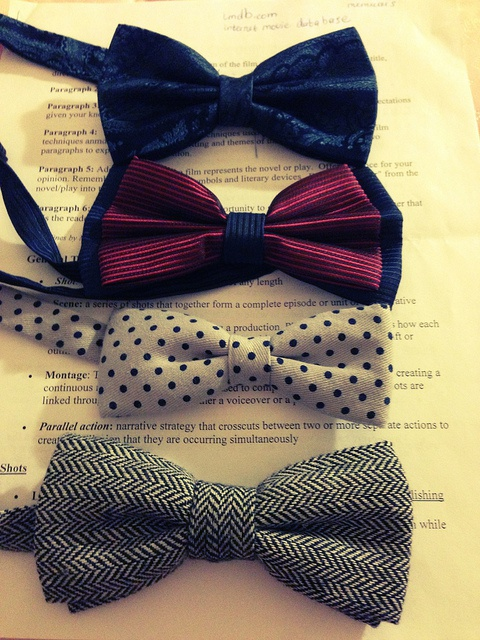Describe the objects in this image and their specific colors. I can see tie in khaki, black, gray, and tan tones, tie in khaki, black, purple, navy, and brown tones, tie in khaki, black, navy, and blue tones, and tie in khaki, gray, tan, and black tones in this image. 